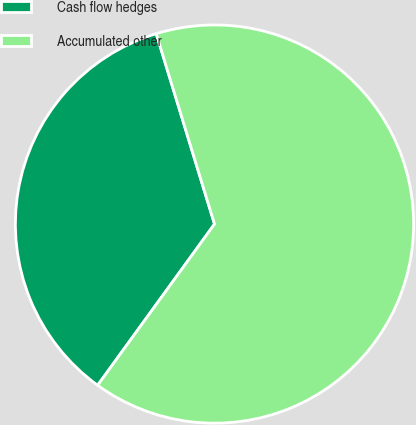Convert chart. <chart><loc_0><loc_0><loc_500><loc_500><pie_chart><fcel>Cash flow hedges<fcel>Accumulated other<nl><fcel>35.29%<fcel>64.71%<nl></chart> 